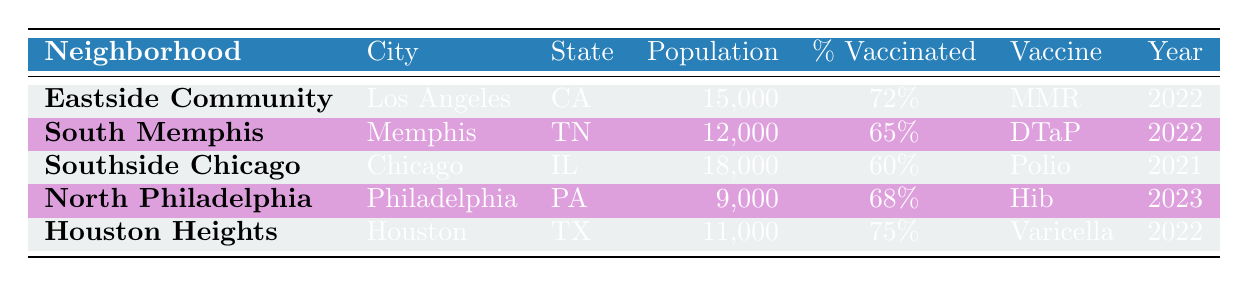What is the vaccination percentage in Eastside Community? The table shows the row for Eastside Community, which indicates a vaccination percentage of 72%.
Answer: 72% Which neighborhood has the lowest percentage of vaccination? Reviewing the vaccination percentages of all neighborhoods listed, Southside Chicago has the lowest at 60%.
Answer: Southside Chicago What is the population of North Philadelphia? In the table, the row for North Philadelphia lists a population of 9,000 individuals.
Answer: 9,000 Is the vaccination percentage in Houston Heights higher than that in South Memphis? Houston Heights has a vaccination percentage of 75%, while South Memphis has 65%. Since 75% is greater than 65%, the statement is true.
Answer: Yes What is the average vaccination percentage for the neighborhoods listed in the table? To find the average, we add the vaccination percentages: (72 + 65 + 60 + 68 + 75) = 340. There are 5 neighborhoods, so the average is 340 / 5 = 68%.
Answer: 68% Which vaccine type has the highest reported vaccination percentage? Comparing the vaccination percentages: MMR (72%), DTaP (65%), Polio (60%), Hib (68%), and Varicella (75%), the Varicella vaccine has the highest percentage at 75%.
Answer: Varicella Are there any neighborhoods where the vaccination percentage is at least 70%? Checking the vaccination percentages: Eastside Community (72%), Houston Heights (75%), and North Philadelphia (68%) shows that there are two neighborhoods (Eastside Community and Houston Heights) with at least 70%.
Answer: Yes If we consider only the neighborhoods from 2022, what is the total population? The relevant neighborhoods from 2022 are Eastside Community (15,000), South Memphis (12,000), and Houston Heights (11,000). Adding these populations gives 15,000 + 12,000 + 11,000 = 38,000.
Answer: 38,000 Which city has a neighborhood with a vaccination rate of exactly 65%? Looking through the table, South Memphis in Memphis, TN has a vaccination rate of exactly 65%.
Answer: Memphis 